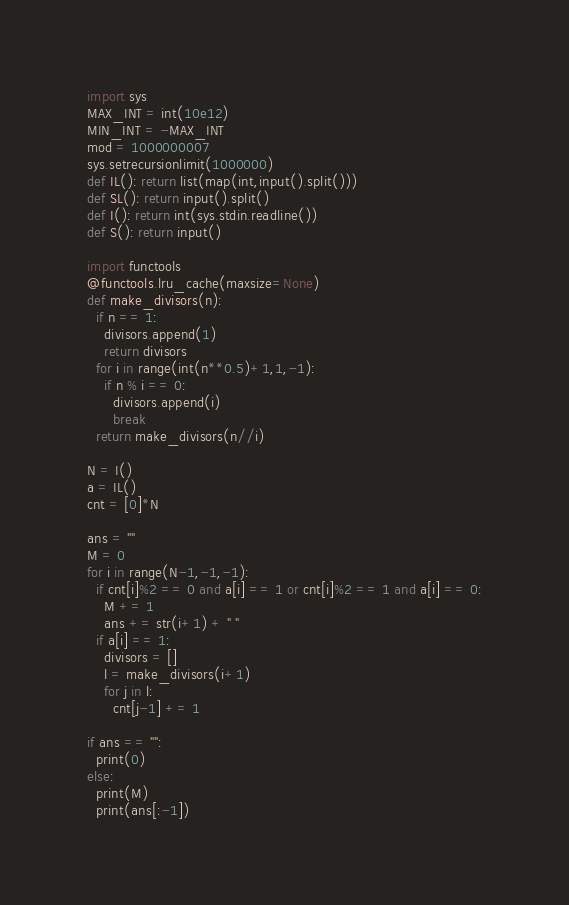<code> <loc_0><loc_0><loc_500><loc_500><_Python_>import sys
MAX_INT = int(10e12)
MIN_INT = -MAX_INT
mod = 1000000007
sys.setrecursionlimit(1000000)
def IL(): return list(map(int,input().split()))
def SL(): return input().split()
def I(): return int(sys.stdin.readline())
def S(): return input()

import functools
@functools.lru_cache(maxsize=None)
def make_divisors(n):
  if n == 1:
    divisors.append(1)
    return divisors
  for i in range(int(n**0.5)+1,1,-1):
    if n % i == 0:
      divisors.append(i)
      break
  return make_divisors(n//i)

N = I()
a = IL()
cnt = [0]*N

ans = ""
M = 0
for i in range(N-1,-1,-1):
  if cnt[i]%2 == 0 and a[i] == 1 or cnt[i]%2 == 1 and a[i] == 0:
    M += 1
    ans += str(i+1) + " "
  if a[i] == 1:
    divisors = []
    l = make_divisors(i+1)
    for j in l:
      cnt[j-1] += 1

if ans == "":
  print(0)
else:
  print(M)
  print(ans[:-1])</code> 